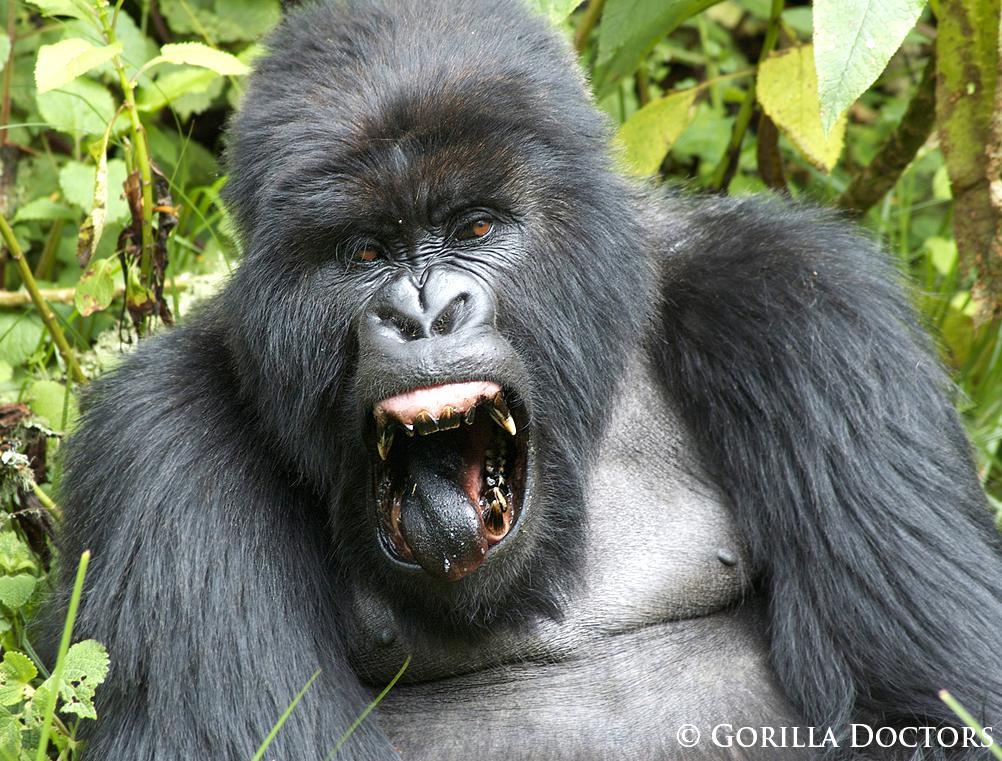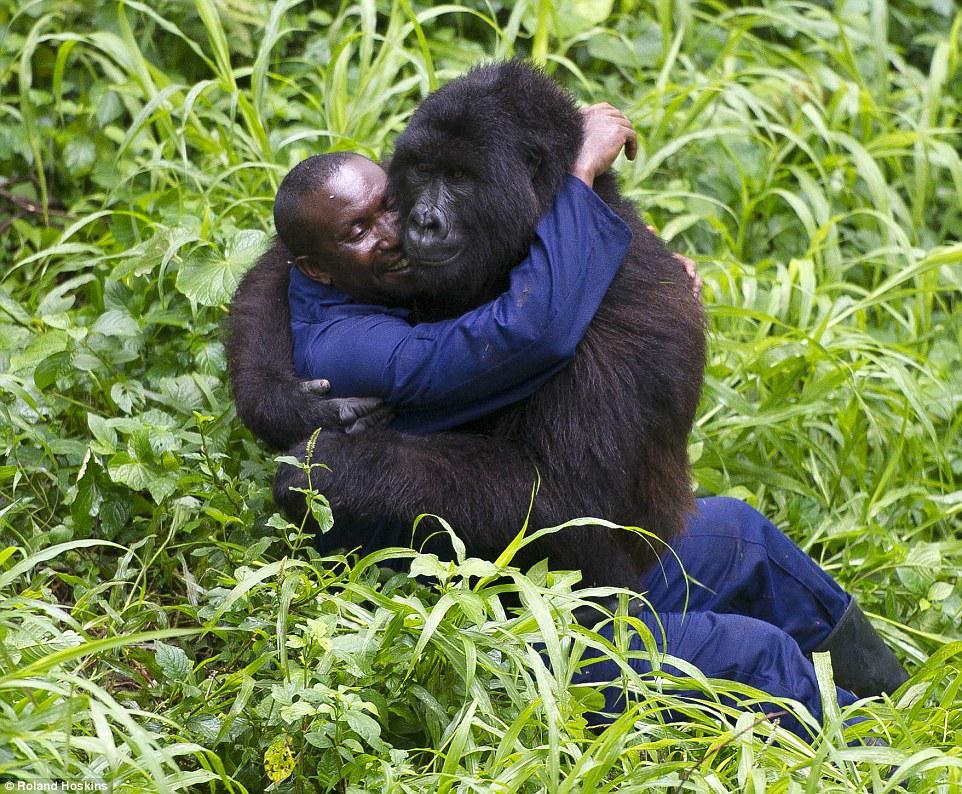The first image is the image on the left, the second image is the image on the right. Evaluate the accuracy of this statement regarding the images: "One image shows a man in an olive-green shirt interacting with a gorilla.". Is it true? Answer yes or no. No. The first image is the image on the left, the second image is the image on the right. For the images displayed, is the sentence "There is a person in the image on the right." factually correct? Answer yes or no. Yes. 